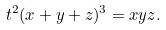<formula> <loc_0><loc_0><loc_500><loc_500>t ^ { 2 } ( x + y + z ) ^ { 3 } = x y z .</formula> 